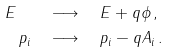<formula> <loc_0><loc_0><loc_500><loc_500>E \quad & \longrightarrow \quad E + q \phi \, , \\ p _ { i } \quad & \longrightarrow \quad p _ { i } - q A _ { i } \, .</formula> 